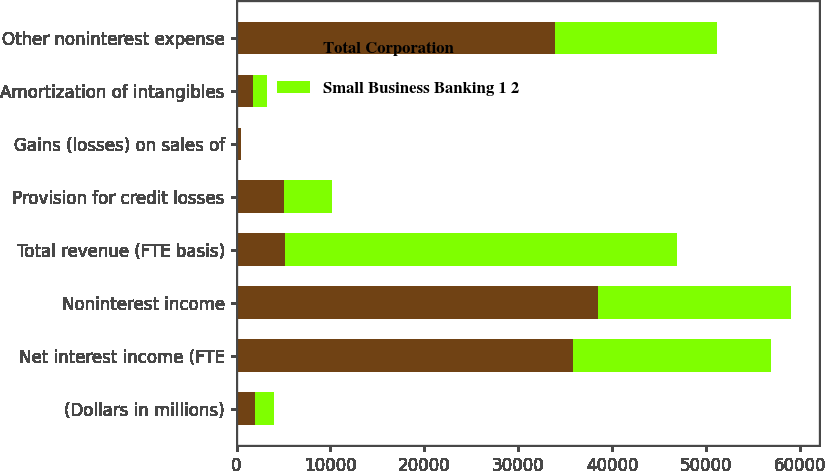<chart> <loc_0><loc_0><loc_500><loc_500><stacked_bar_chart><ecel><fcel>(Dollars in millions)<fcel>Net interest income (FTE<fcel>Noninterest income<fcel>Total revenue (FTE basis)<fcel>Provision for credit losses<fcel>Gains (losses) on sales of<fcel>Amortization of intangibles<fcel>Other noninterest expense<nl><fcel>Total Corporation<fcel>2006<fcel>35815<fcel>38432<fcel>5172<fcel>5010<fcel>443<fcel>1755<fcel>33842<nl><fcel>Small Business Banking 1 2<fcel>2006<fcel>21100<fcel>20591<fcel>41691<fcel>5172<fcel>1<fcel>1511<fcel>17319<nl></chart> 